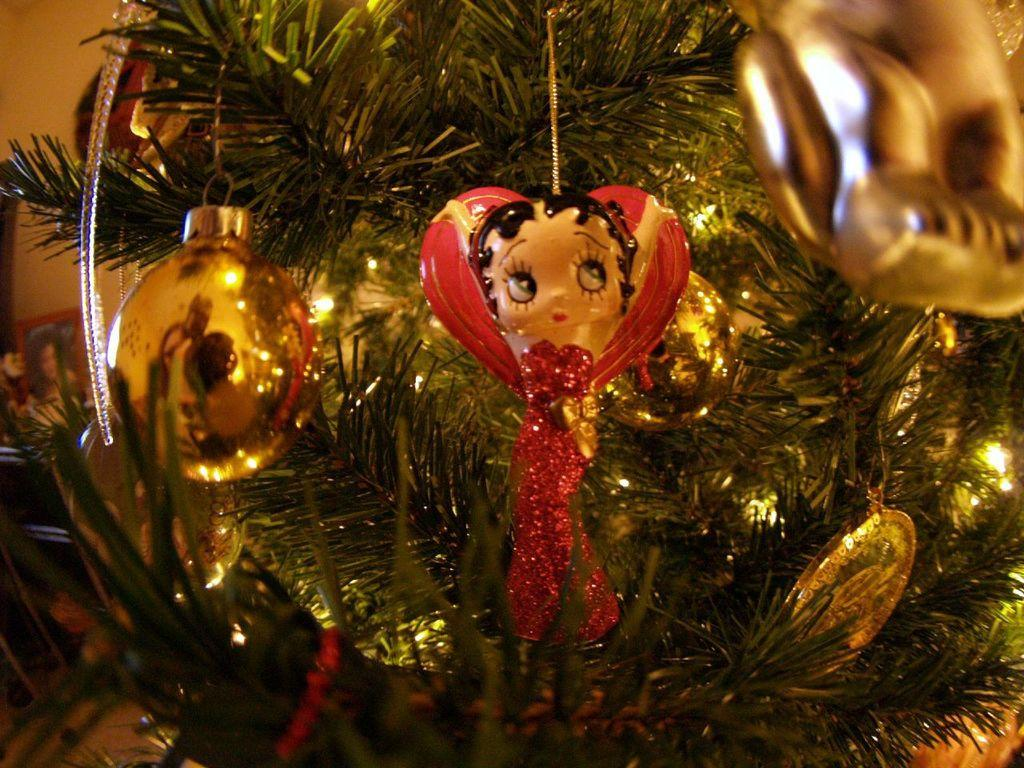What is the main subject of the image? There is a Christmas tree in the image. How is the Christmas tree decorated? The Christmas tree is decorated in the image. Where is the Christmas tree located in the image? The Christmas tree is in the center of the image. What can be seen on the Christmas tree? Christmas ornaments are present on the tree. How much does the grandmother's muscle weigh in the image? There is no grandmother or muscle present in the image. 